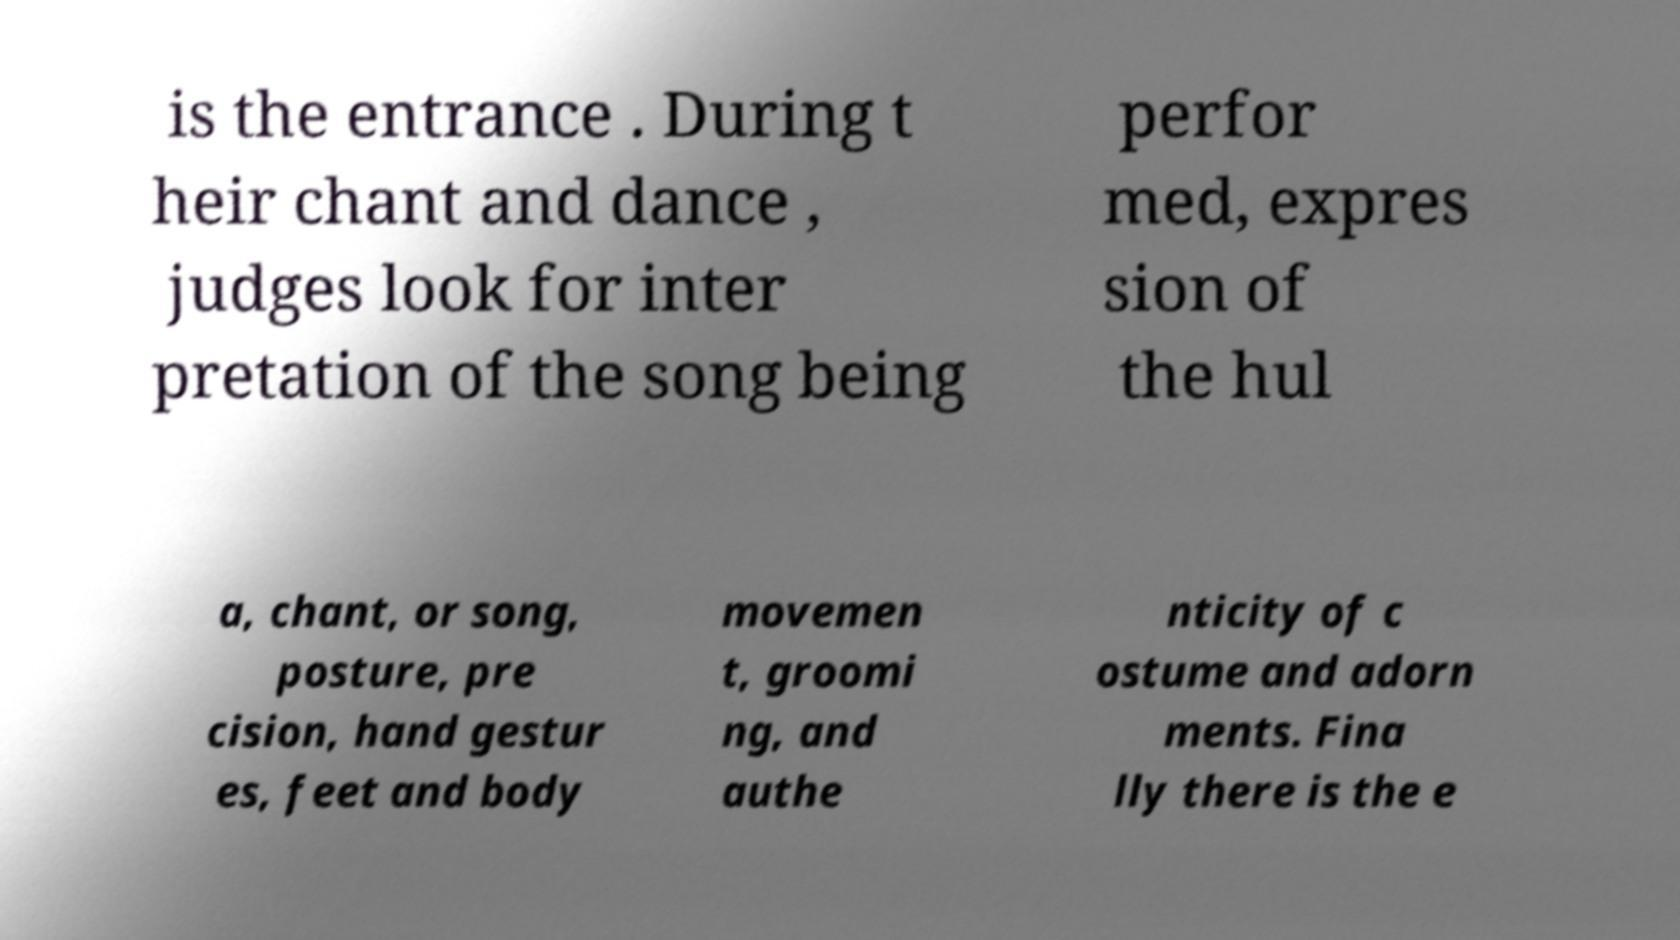Could you extract and type out the text from this image? is the entrance . During t heir chant and dance , judges look for inter pretation of the song being perfor med, expres sion of the hul a, chant, or song, posture, pre cision, hand gestur es, feet and body movemen t, groomi ng, and authe nticity of c ostume and adorn ments. Fina lly there is the e 